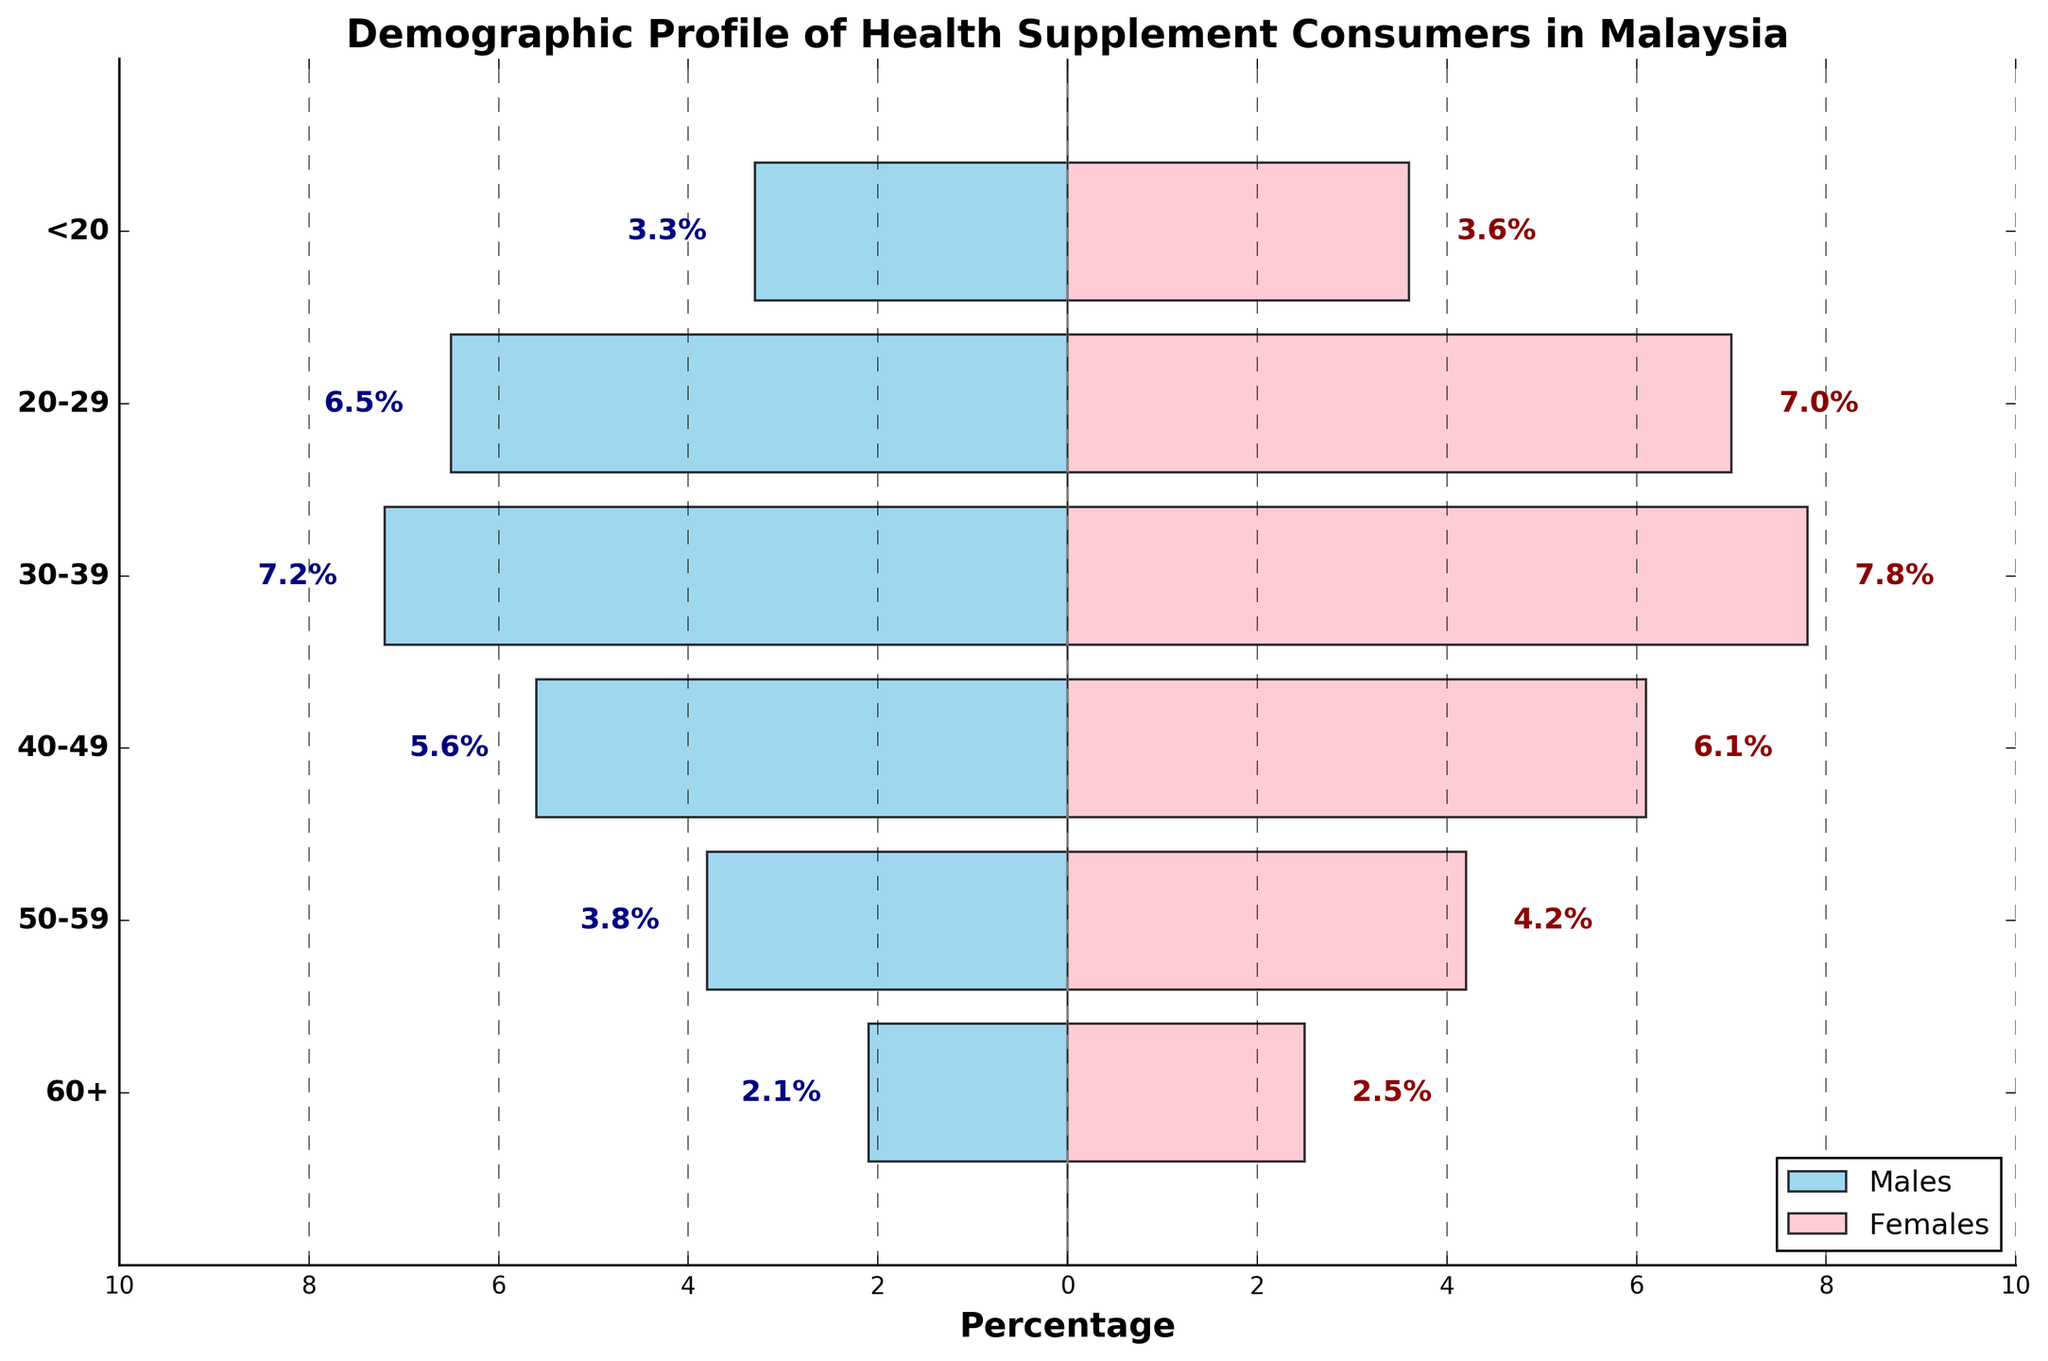What is the title of the figure? The title of the figure is located at the top of the chart.
Answer: Demographic Profile of Health Supplement Consumers in Malaysia Which age group has the highest percentage of female consumers? By observing the lengths of the pink bars on the right, the highest percentage is for the 30-39 age group.
Answer: 30-39 What is the percentage of male consumers in the 50-59 age group? The negative length of the skyblue bar for the 50-59 age group indicates the percentage.
Answer: 3.8% Are there more male or female consumers in the 20-29 age group? By comparing the lengths of the bars for the 20-29 age group: 6.5% (males) and 7.0% (females), females have a higher percentage.
Answer: Female What is the sum of the percentages for male and female consumers in the 40-49 age group? By adding the percentages for males (5.6%) and females (6.1%) in the 40-49 age group: 5.6 + 6.1 = 11.7.
Answer: 11.7% Which age group has the smallest gender gap in percentage terms? The gender gap can be determined by finding the differences between male and female percentages for each age group. The smallest difference is for the 20-29 age group: 7.0% - 6.5% = 0.5%.
Answer: 20-29 How does the percentage of male consumers below 20 years old compare to those aged 60+? The percentage of male consumers below 20 is 3.3%, while for 60+ it is 2.1%. 3.3 is greater than 2.1.
Answer: Greater What trend do you see in the percentage of female consumers as the age group increases from below 20 to 60+? The percentages generally increase from below 20 (3.6%), peaking in 30-39 (7.8%), before slightly declining to 2.5% in 60+.
Answer: Increasing then decreasing Which age group's total percentage for both genders combined is closest to 10%? Adding the percentages for each age group: <20 (6.9), 20-29 (13.5), 30-39 (15.0), 40-49 (11.7), 50-59 (8.0), 60+ (4.6), the closest to 10% is the 50-59 age group with 8.0%.
Answer: 50-59 What can you infer about the consumption of health supplements among older adults (60+) compared to younger adults (20-29)? Comparing the combined percentages of 60+ (4.6) and 20-29 (13.5), younger adults have a notably higher percentage than older adults.
Answer: Higher for younger adults 